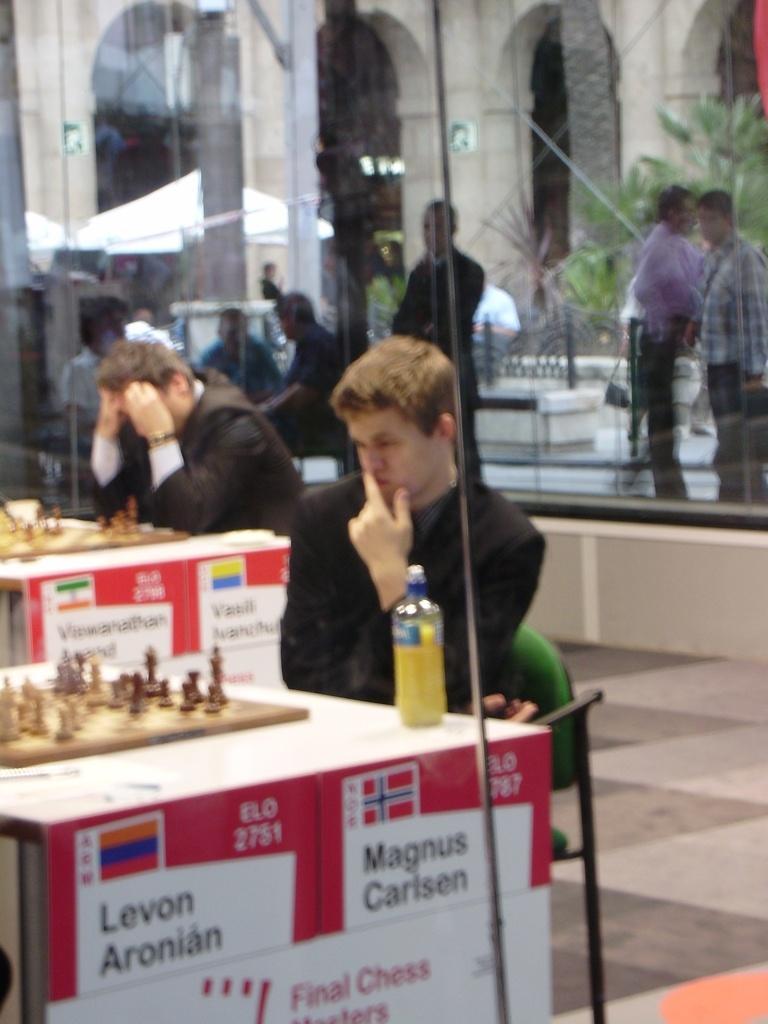Could you give a brief overview of what you see in this image? In this picture we can see there are two men sitting. In front of the men, there are chess boards, chess pieces and boards. Behind the transparent glass, there are people, trees, iron grilles and a building. 